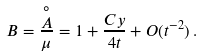<formula> <loc_0><loc_0><loc_500><loc_500>B = \frac { \stackrel { \circ } { A } } \mu = 1 + \frac { C y } { 4 t } + O ( t ^ { - 2 } ) \, .</formula> 